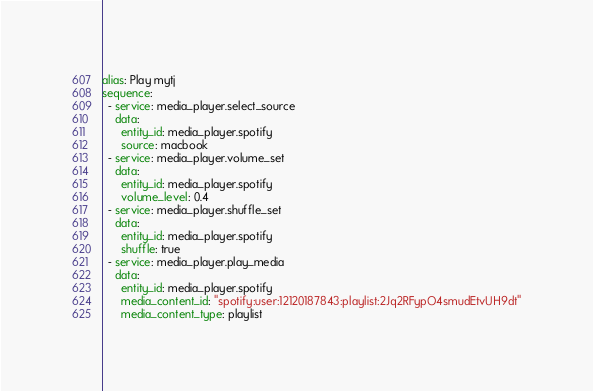Convert code to text. <code><loc_0><loc_0><loc_500><loc_500><_YAML_>alias: Play mytj
sequence:
  - service: media_player.select_source
    data:
      entity_id: media_player.spotify
      source: macbook
  - service: media_player.volume_set
    data:
      entity_id: media_player.spotify
      volume_level: 0.4
  - service: media_player.shuffle_set
    data:
      entity_id: media_player.spotify
      shuffle: true
  - service: media_player.play_media
    data:
      entity_id: media_player.spotify
      media_content_id: "spotify:user:12120187843:playlist:2Jq2RFypO4smudEtvUH9dt"
      media_content_type: playlist
</code> 